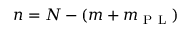<formula> <loc_0><loc_0><loc_500><loc_500>n = N - ( m + m _ { P L } )</formula> 